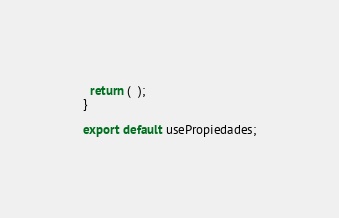<code> <loc_0><loc_0><loc_500><loc_500><_JavaScript_>  return (  );
}

export default usePropiedades;</code> 